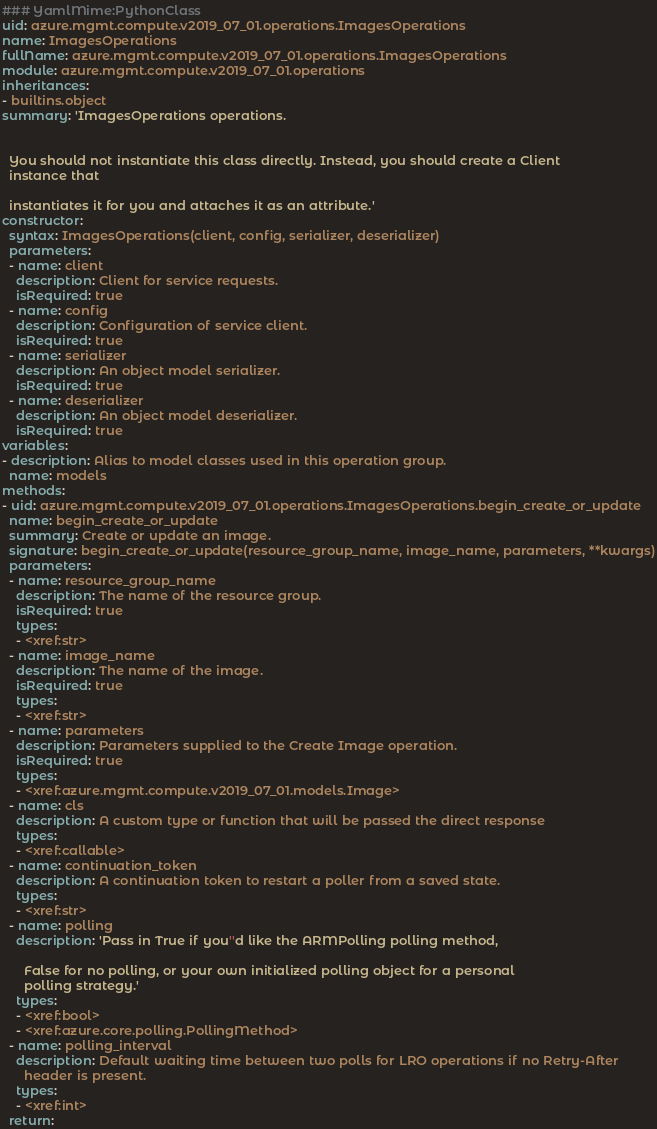Convert code to text. <code><loc_0><loc_0><loc_500><loc_500><_YAML_>### YamlMime:PythonClass
uid: azure.mgmt.compute.v2019_07_01.operations.ImagesOperations
name: ImagesOperations
fullName: azure.mgmt.compute.v2019_07_01.operations.ImagesOperations
module: azure.mgmt.compute.v2019_07_01.operations
inheritances:
- builtins.object
summary: 'ImagesOperations operations.


  You should not instantiate this class directly. Instead, you should create a Client
  instance that

  instantiates it for you and attaches it as an attribute.'
constructor:
  syntax: ImagesOperations(client, config, serializer, deserializer)
  parameters:
  - name: client
    description: Client for service requests.
    isRequired: true
  - name: config
    description: Configuration of service client.
    isRequired: true
  - name: serializer
    description: An object model serializer.
    isRequired: true
  - name: deserializer
    description: An object model deserializer.
    isRequired: true
variables:
- description: Alias to model classes used in this operation group.
  name: models
methods:
- uid: azure.mgmt.compute.v2019_07_01.operations.ImagesOperations.begin_create_or_update
  name: begin_create_or_update
  summary: Create or update an image.
  signature: begin_create_or_update(resource_group_name, image_name, parameters, **kwargs)
  parameters:
  - name: resource_group_name
    description: The name of the resource group.
    isRequired: true
    types:
    - <xref:str>
  - name: image_name
    description: The name of the image.
    isRequired: true
    types:
    - <xref:str>
  - name: parameters
    description: Parameters supplied to the Create Image operation.
    isRequired: true
    types:
    - <xref:azure.mgmt.compute.v2019_07_01.models.Image>
  - name: cls
    description: A custom type or function that will be passed the direct response
    types:
    - <xref:callable>
  - name: continuation_token
    description: A continuation token to restart a poller from a saved state.
    types:
    - <xref:str>
  - name: polling
    description: 'Pass in True if you''d like the ARMPolling polling method,

      False for no polling, or your own initialized polling object for a personal
      polling strategy.'
    types:
    - <xref:bool>
    - <xref:azure.core.polling.PollingMethod>
  - name: polling_interval
    description: Default waiting time between two polls for LRO operations if no Retry-After
      header is present.
    types:
    - <xref:int>
  return:</code> 